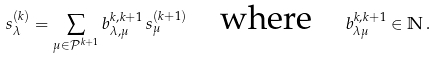<formula> <loc_0><loc_0><loc_500><loc_500>s _ { \lambda } ^ { ( k ) } = \sum _ { \mu \in \mathcal { P } ^ { k + 1 } } b _ { \lambda , \mu } ^ { k , k + 1 } \, s _ { \mu } ^ { ( k + 1 ) } \quad \text {where} \quad b _ { \lambda \mu } ^ { k , k + 1 } \in \mathbb { N } \, .</formula> 